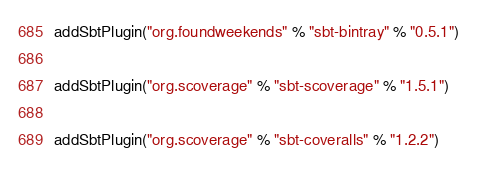Convert code to text. <code><loc_0><loc_0><loc_500><loc_500><_Scala_>addSbtPlugin("org.foundweekends" % "sbt-bintray" % "0.5.1")

addSbtPlugin("org.scoverage" % "sbt-scoverage" % "1.5.1")

addSbtPlugin("org.scoverage" % "sbt-coveralls" % "1.2.2")</code> 